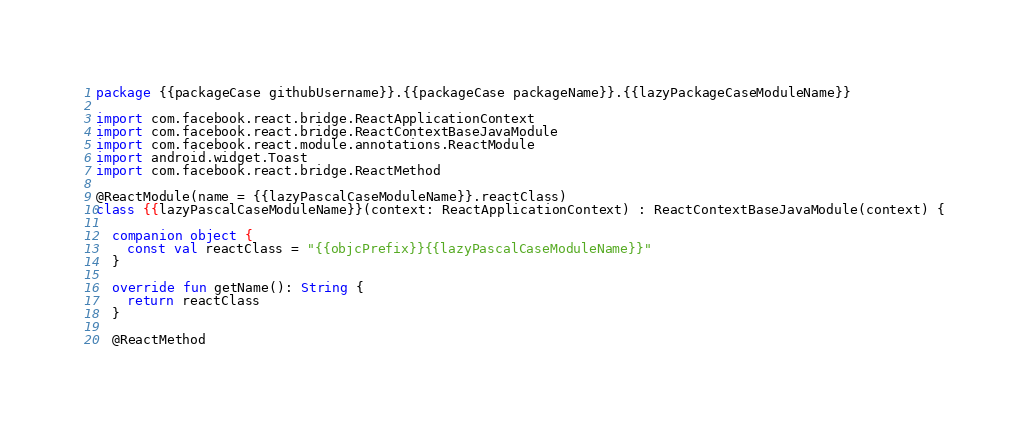<code> <loc_0><loc_0><loc_500><loc_500><_Kotlin_>package {{packageCase githubUsername}}.{{packageCase packageName}}.{{lazyPackageCaseModuleName}}

import com.facebook.react.bridge.ReactApplicationContext
import com.facebook.react.bridge.ReactContextBaseJavaModule
import com.facebook.react.module.annotations.ReactModule
import android.widget.Toast
import com.facebook.react.bridge.ReactMethod

@ReactModule(name = {{lazyPascalCaseModuleName}}.reactClass)
class {{lazyPascalCaseModuleName}}(context: ReactApplicationContext) : ReactContextBaseJavaModule(context) {

  companion object {
    const val reactClass = "{{objcPrefix}}{{lazyPascalCaseModuleName}}"
  }

  override fun getName(): String {
    return reactClass
  }

  @ReactMethod</code> 